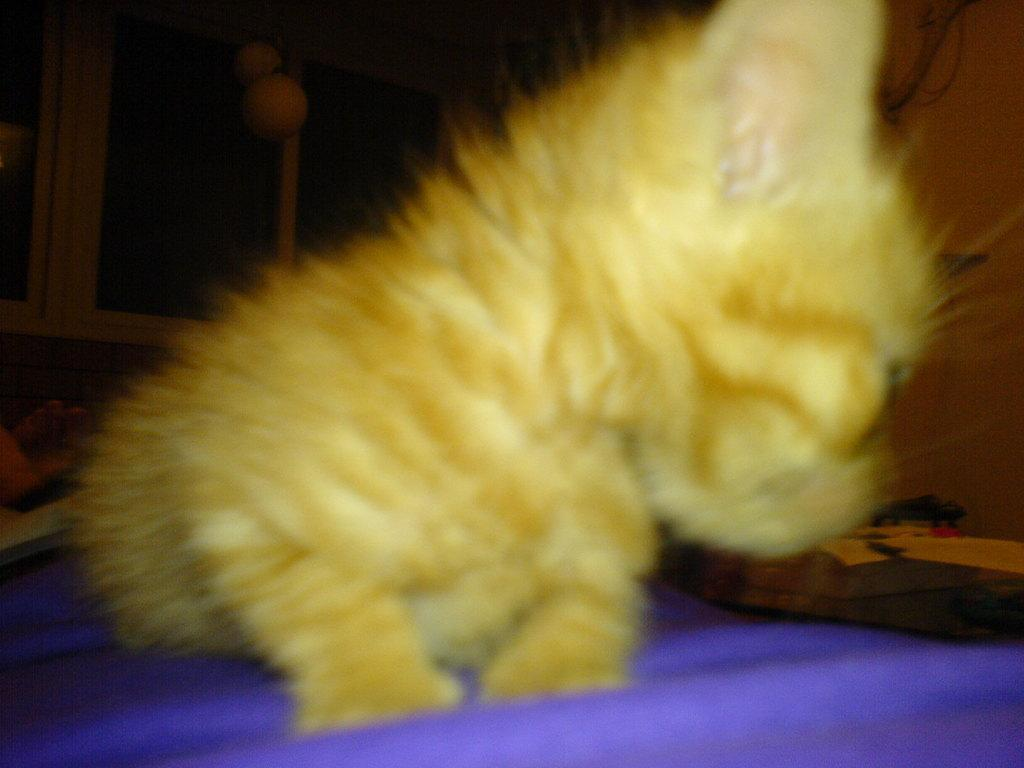What color is the animal in the image? The animal in the image is yellow. What is the animal sitting on? The animal is sitting on a violet bed sheet. What type of cable can be seen connecting the animal to the prison in the image? There is no cable or prison present in the image; it only features a yellow animal sitting on a violet bed sheet. 